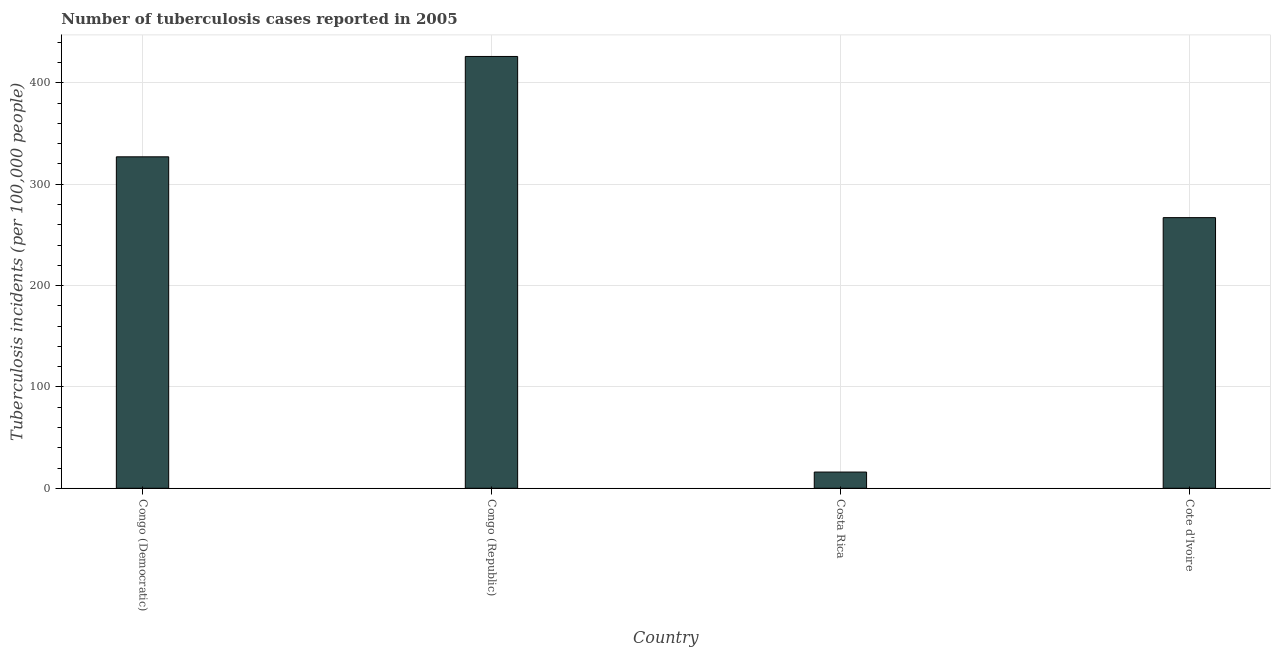What is the title of the graph?
Offer a very short reply. Number of tuberculosis cases reported in 2005. What is the label or title of the X-axis?
Give a very brief answer. Country. What is the label or title of the Y-axis?
Your answer should be compact. Tuberculosis incidents (per 100,0 people). What is the number of tuberculosis incidents in Congo (Democratic)?
Provide a succinct answer. 327. Across all countries, what is the maximum number of tuberculosis incidents?
Your response must be concise. 426. Across all countries, what is the minimum number of tuberculosis incidents?
Offer a very short reply. 16. In which country was the number of tuberculosis incidents maximum?
Ensure brevity in your answer.  Congo (Republic). What is the sum of the number of tuberculosis incidents?
Your answer should be compact. 1036. What is the average number of tuberculosis incidents per country?
Your answer should be very brief. 259. What is the median number of tuberculosis incidents?
Offer a very short reply. 297. What is the ratio of the number of tuberculosis incidents in Congo (Democratic) to that in Cote d'Ivoire?
Keep it short and to the point. 1.23. Is the number of tuberculosis incidents in Congo (Republic) less than that in Cote d'Ivoire?
Keep it short and to the point. No. Is the difference between the number of tuberculosis incidents in Congo (Democratic) and Cote d'Ivoire greater than the difference between any two countries?
Your answer should be very brief. No. What is the difference between the highest and the lowest number of tuberculosis incidents?
Your answer should be compact. 410. How many bars are there?
Provide a succinct answer. 4. Are all the bars in the graph horizontal?
Your response must be concise. No. How many countries are there in the graph?
Your response must be concise. 4. Are the values on the major ticks of Y-axis written in scientific E-notation?
Make the answer very short. No. What is the Tuberculosis incidents (per 100,000 people) in Congo (Democratic)?
Offer a very short reply. 327. What is the Tuberculosis incidents (per 100,000 people) in Congo (Republic)?
Your answer should be compact. 426. What is the Tuberculosis incidents (per 100,000 people) of Cote d'Ivoire?
Offer a terse response. 267. What is the difference between the Tuberculosis incidents (per 100,000 people) in Congo (Democratic) and Congo (Republic)?
Your answer should be very brief. -99. What is the difference between the Tuberculosis incidents (per 100,000 people) in Congo (Democratic) and Costa Rica?
Give a very brief answer. 311. What is the difference between the Tuberculosis incidents (per 100,000 people) in Congo (Republic) and Costa Rica?
Provide a short and direct response. 410. What is the difference between the Tuberculosis incidents (per 100,000 people) in Congo (Republic) and Cote d'Ivoire?
Offer a terse response. 159. What is the difference between the Tuberculosis incidents (per 100,000 people) in Costa Rica and Cote d'Ivoire?
Keep it short and to the point. -251. What is the ratio of the Tuberculosis incidents (per 100,000 people) in Congo (Democratic) to that in Congo (Republic)?
Offer a very short reply. 0.77. What is the ratio of the Tuberculosis incidents (per 100,000 people) in Congo (Democratic) to that in Costa Rica?
Provide a succinct answer. 20.44. What is the ratio of the Tuberculosis incidents (per 100,000 people) in Congo (Democratic) to that in Cote d'Ivoire?
Provide a succinct answer. 1.23. What is the ratio of the Tuberculosis incidents (per 100,000 people) in Congo (Republic) to that in Costa Rica?
Provide a succinct answer. 26.62. What is the ratio of the Tuberculosis incidents (per 100,000 people) in Congo (Republic) to that in Cote d'Ivoire?
Your answer should be compact. 1.6. 